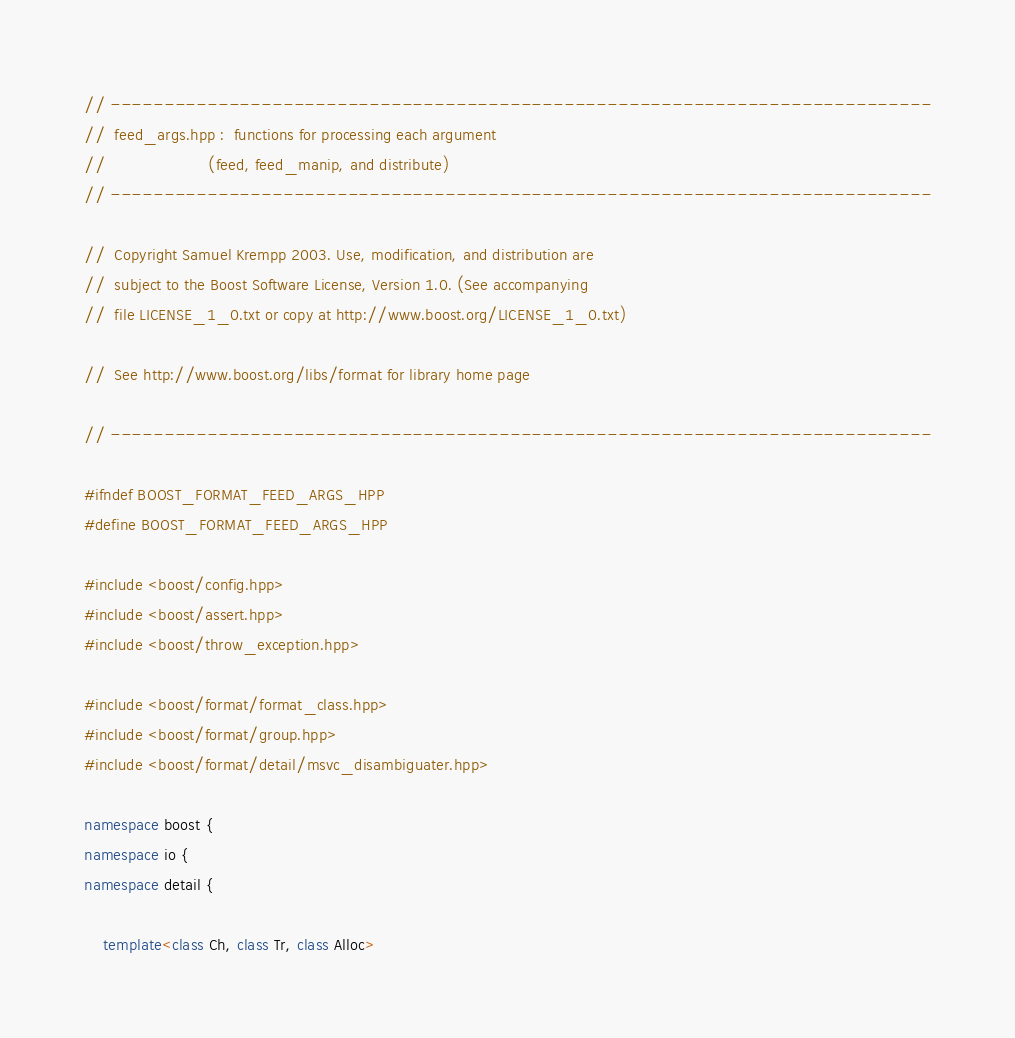<code> <loc_0><loc_0><loc_500><loc_500><_C++_>// ----------------------------------------------------------------------------
//  feed_args.hpp :  functions for processing each argument 
//                      (feed, feed_manip, and distribute)
// ----------------------------------------------------------------------------

//  Copyright Samuel Krempp 2003. Use, modification, and distribution are
//  subject to the Boost Software License, Version 1.0. (See accompanying
//  file LICENSE_1_0.txt or copy at http://www.boost.org/LICENSE_1_0.txt)

//  See http://www.boost.org/libs/format for library home page

// ----------------------------------------------------------------------------

#ifndef BOOST_FORMAT_FEED_ARGS_HPP
#define BOOST_FORMAT_FEED_ARGS_HPP

#include <boost/config.hpp>
#include <boost/assert.hpp>
#include <boost/throw_exception.hpp>

#include <boost/format/format_class.hpp>
#include <boost/format/group.hpp>
#include <boost/format/detail/msvc_disambiguater.hpp>

namespace boost {
namespace io {
namespace detail {

    template<class Ch, class Tr, class Alloc></code> 